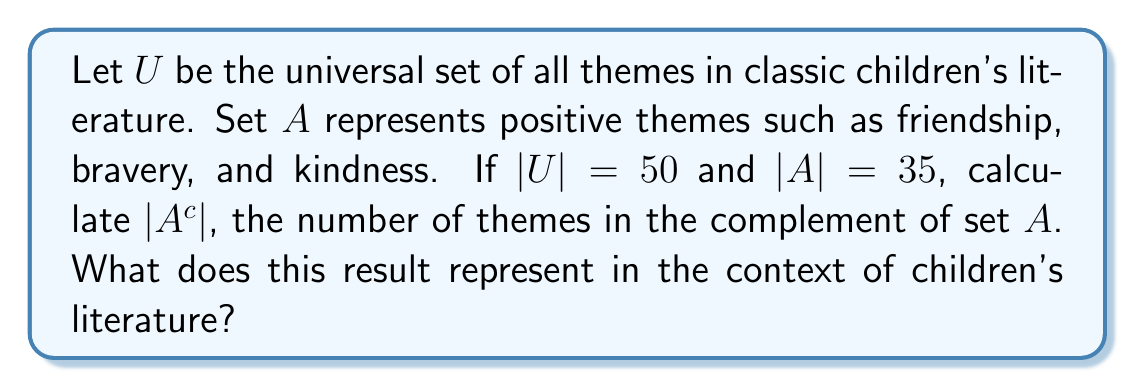Can you answer this question? To solve this problem, we need to understand the concept of complement sets and use the given information:

1) The universal set $U$ contains all themes in classic children's literature.
2) Set $A$ represents positive themes.
3) $|U| = 50$ (total number of themes)
4) $|A| = 35$ (number of positive themes)

The complement of set $A$, denoted as $A^c$, contains all elements in the universal set $U$ that are not in $A$. In this context, $A^c$ would represent themes that are not considered positive.

To calculate $|A^c|$, we can use the following formula:

$$|A^c| = |U| - |A|$$

Substituting the given values:

$$|A^c| = 50 - 35 = 15$$

This result represents the number of themes in classic children's literature that are not considered positive. These could include neutral themes or potentially negative ones, but it's important to note that classic children's literature generally aims to be uplifting and instructive, so these themes are likely not overtly dark or disturbing.
Answer: $|A^c| = 15$

This represents the number of themes in classic children's literature that are not categorized as positive. These could be neutral themes or those that present challenges for characters to overcome, contributing to the overall narrative without being explicitly positive. 